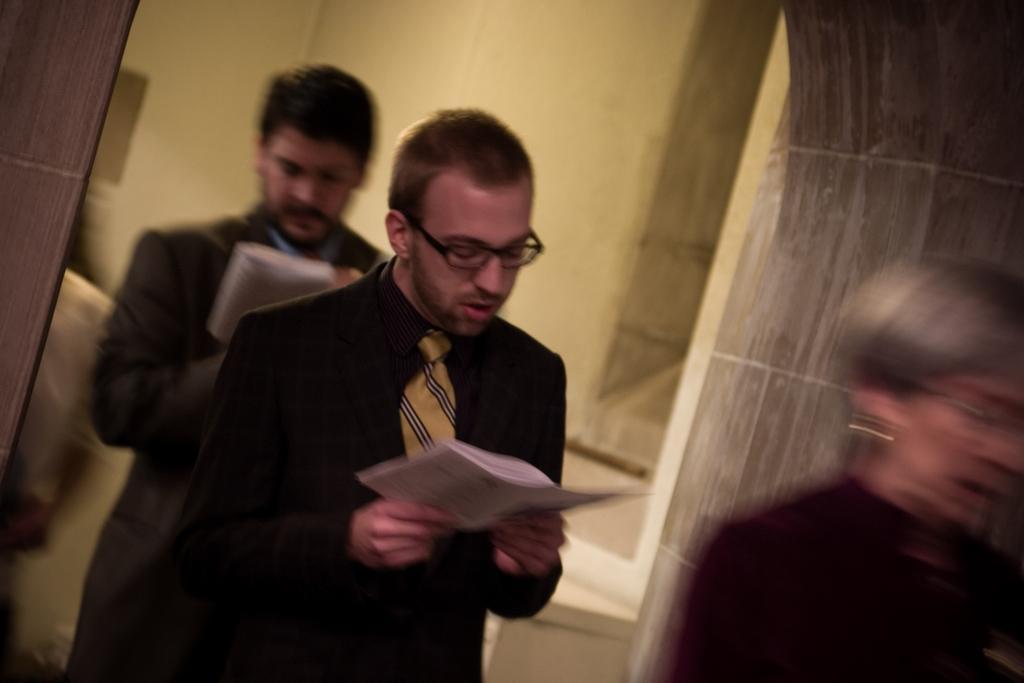In one or two sentences, can you explain what this image depicts? In this image, we can see people standing and some are wearing glasses and some are holding papers in their hands. In the background, there is a wall. 